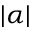Convert formula to latex. <formula><loc_0><loc_0><loc_500><loc_500>| \alpha |</formula> 